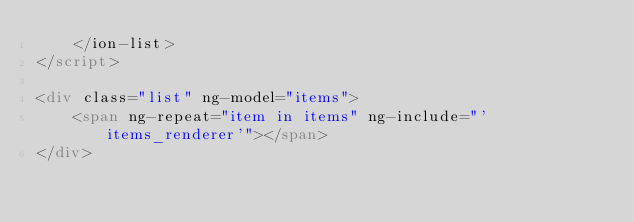<code> <loc_0><loc_0><loc_500><loc_500><_HTML_>    </ion-list>
</script>

<div class="list" ng-model="items">
    <span ng-repeat="item in items" ng-include="'items_renderer'"></span>
</div></code> 